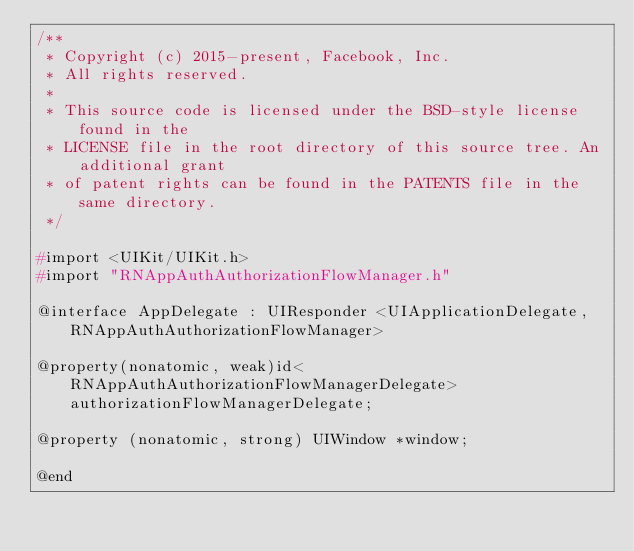<code> <loc_0><loc_0><loc_500><loc_500><_C_>/**
 * Copyright (c) 2015-present, Facebook, Inc.
 * All rights reserved.
 *
 * This source code is licensed under the BSD-style license found in the
 * LICENSE file in the root directory of this source tree. An additional grant
 * of patent rights can be found in the PATENTS file in the same directory.
 */

#import <UIKit/UIKit.h>
#import "RNAppAuthAuthorizationFlowManager.h"

@interface AppDelegate : UIResponder <UIApplicationDelegate, RNAppAuthAuthorizationFlowManager>

@property(nonatomic, weak)id<RNAppAuthAuthorizationFlowManagerDelegate>authorizationFlowManagerDelegate;

@property (nonatomic, strong) UIWindow *window;

@end
</code> 